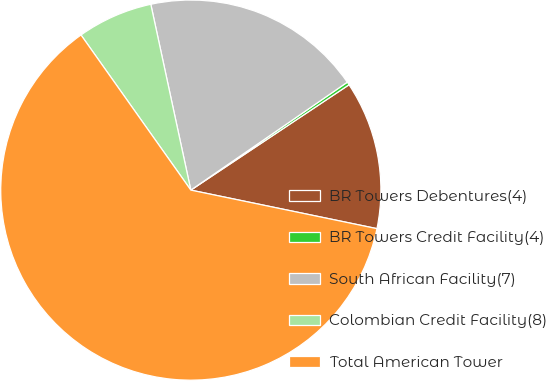<chart> <loc_0><loc_0><loc_500><loc_500><pie_chart><fcel>BR Towers Debentures(4)<fcel>BR Towers Credit Facility(4)<fcel>South African Facility(7)<fcel>Colombian Credit Facility(8)<fcel>Total American Tower<nl><fcel>12.6%<fcel>0.26%<fcel>18.77%<fcel>6.43%<fcel>61.95%<nl></chart> 